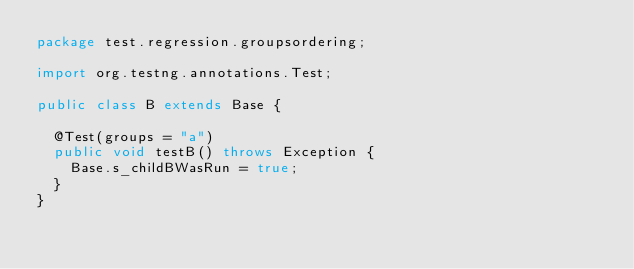Convert code to text. <code><loc_0><loc_0><loc_500><loc_500><_Java_>package test.regression.groupsordering;

import org.testng.annotations.Test;

public class B extends Base {

  @Test(groups = "a")
  public void testB() throws Exception {
    Base.s_childBWasRun = true;
  }
}
</code> 